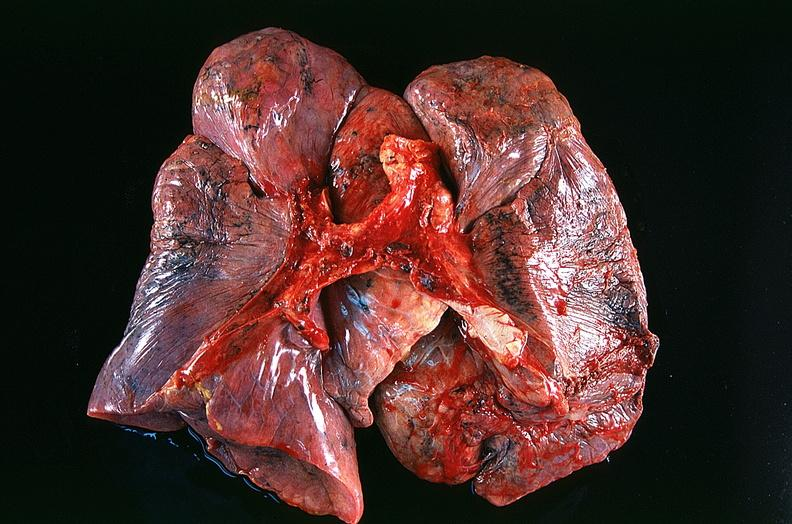does this image show lung, squamous cell carcinoma?
Answer the question using a single word or phrase. Yes 